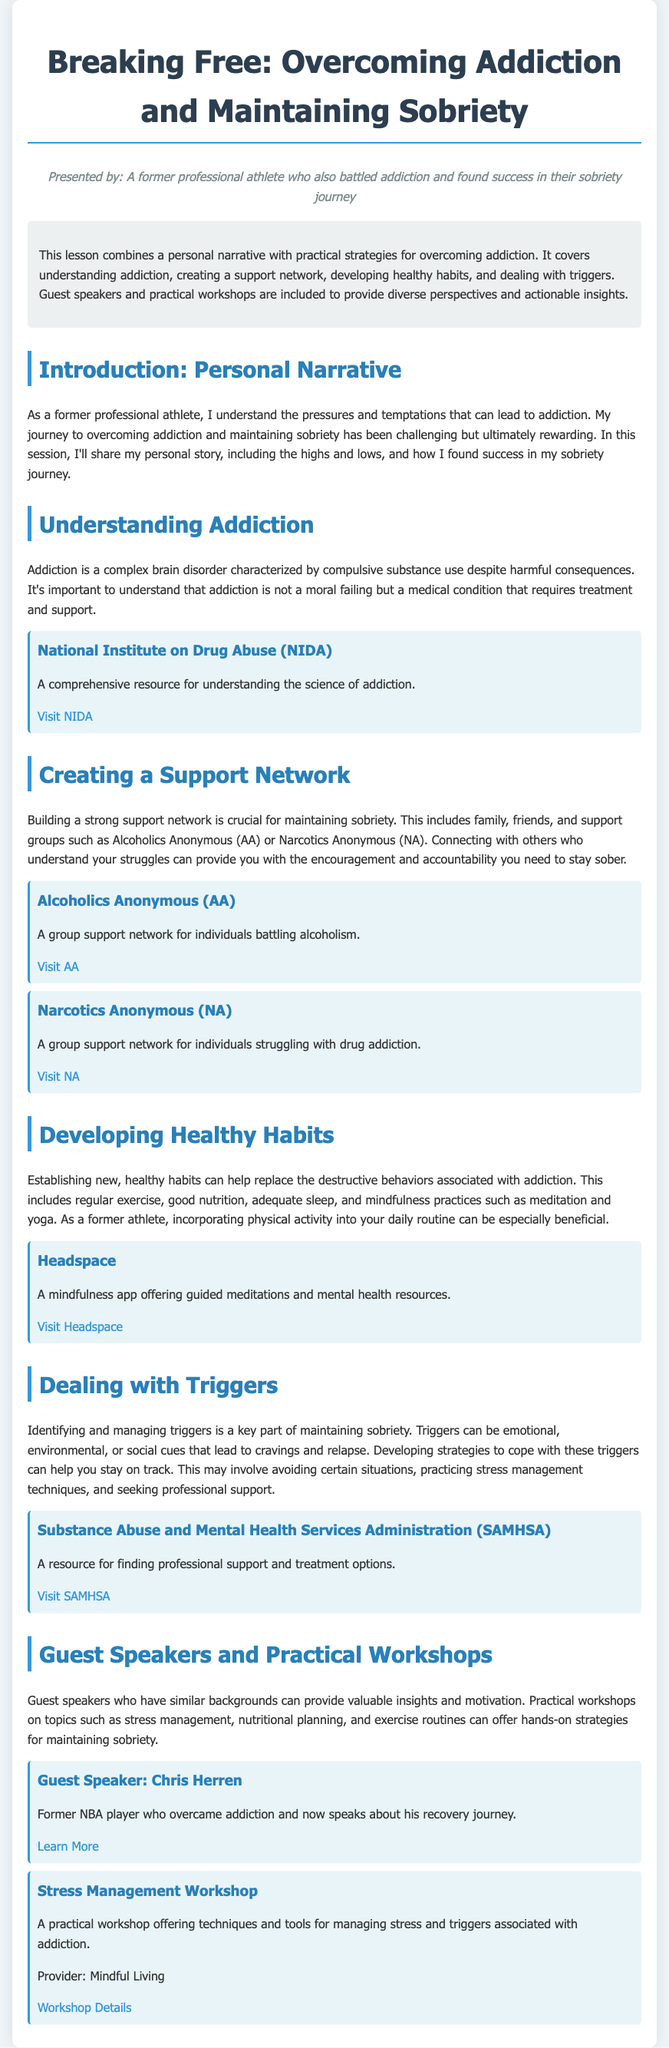What is the title of the lesson plan? The title of the lesson plan is provided in the header of the document.
Answer: Breaking Free: Overcoming Addiction and Maintaining Sobriety Who is the presenter of the lesson? The presenter is introduced in the persona section, highlighting their background.
Answer: A former professional athlete who also battled addiction and found success in their sobriety journey What organization provides a resource for understanding addiction? The document lists the National Institute on Drug Abuse (NIDA) as a resource.
Answer: National Institute on Drug Abuse (NIDA) Which guest speaker is mentioned? The guest speaker section highlights a prominent individual related to the topic.
Answer: Chris Herren What type of workshop is included in the lesson plan? The lesson plan includes a workshop that focuses on a specific skill related to overcoming addiction.
Answer: Stress Management Workshop How many resources are provided under the section "Creating a Support Network"? The document lists multiple resources, specifically from recognized support organizations.
Answer: 2 